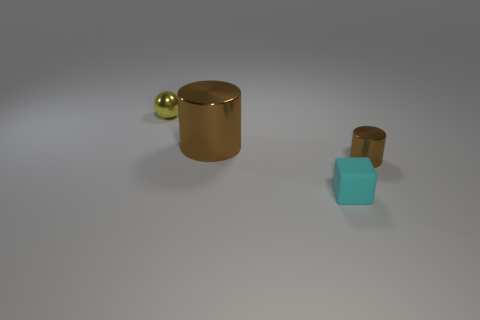Add 3 brown spheres. How many objects exist? 7 Subtract all cubes. How many objects are left? 3 Add 2 large cylinders. How many large cylinders are left? 3 Add 3 cyan matte objects. How many cyan matte objects exist? 4 Subtract 0 yellow blocks. How many objects are left? 4 Subtract all yellow matte spheres. Subtract all tiny cyan objects. How many objects are left? 3 